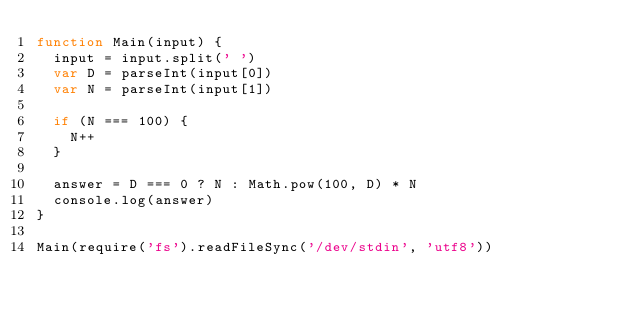<code> <loc_0><loc_0><loc_500><loc_500><_JavaScript_>function Main(input) {
  input = input.split(' ')
  var D = parseInt(input[0])
  var N = parseInt(input[1])

  if (N === 100) {
    N++
  }

  answer = D === 0 ? N : Math.pow(100, D) * N
  console.log(answer)
}

Main(require('fs').readFileSync('/dev/stdin', 'utf8'))

</code> 